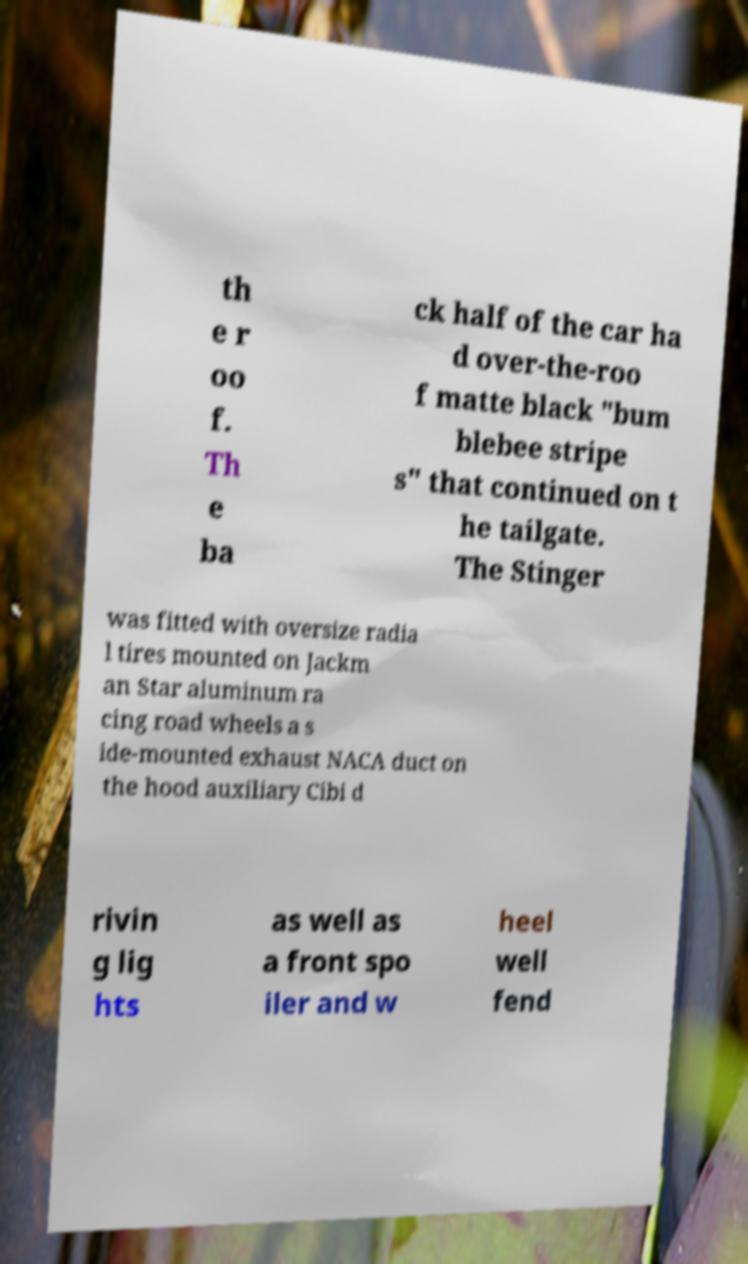Could you assist in decoding the text presented in this image and type it out clearly? th e r oo f. Th e ba ck half of the car ha d over-the-roo f matte black "bum blebee stripe s" that continued on t he tailgate. The Stinger was fitted with oversize radia l tires mounted on Jackm an Star aluminum ra cing road wheels a s ide-mounted exhaust NACA duct on the hood auxiliary Cibi d rivin g lig hts as well as a front spo iler and w heel well fend 